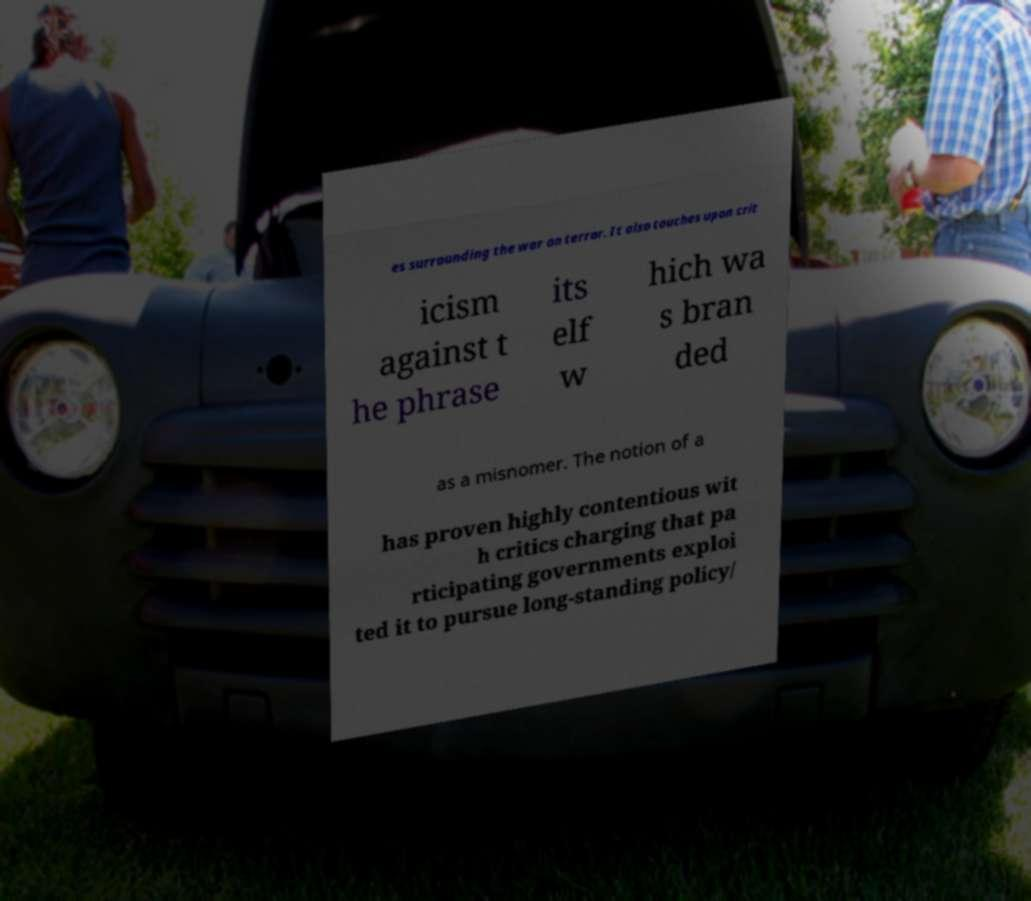What messages or text are displayed in this image? I need them in a readable, typed format. es surrounding the war on terror. It also touches upon crit icism against t he phrase its elf w hich wa s bran ded as a misnomer. The notion of a has proven highly contentious wit h critics charging that pa rticipating governments exploi ted it to pursue long-standing policy/ 